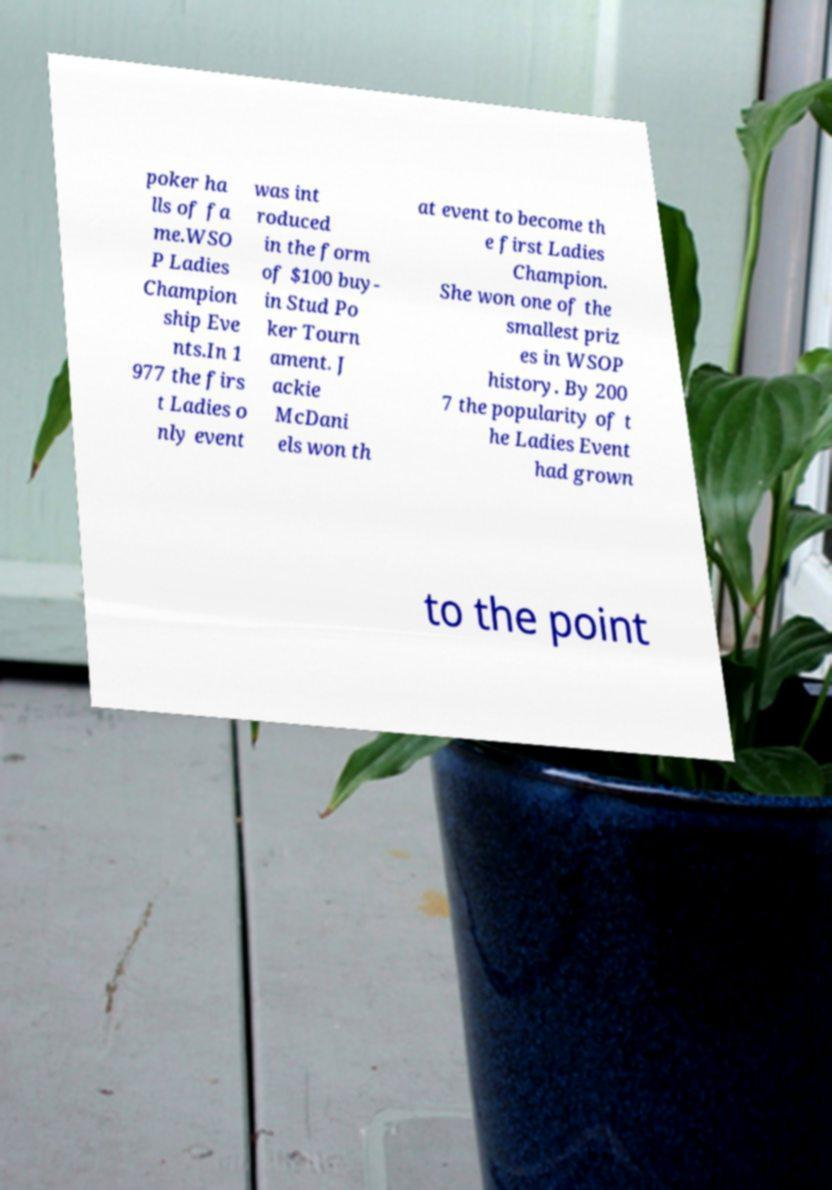Please identify and transcribe the text found in this image. poker ha lls of fa me.WSO P Ladies Champion ship Eve nts.In 1 977 the firs t Ladies o nly event was int roduced in the form of $100 buy- in Stud Po ker Tourn ament. J ackie McDani els won th at event to become th e first Ladies Champion. She won one of the smallest priz es in WSOP history. By 200 7 the popularity of t he Ladies Event had grown to the point 